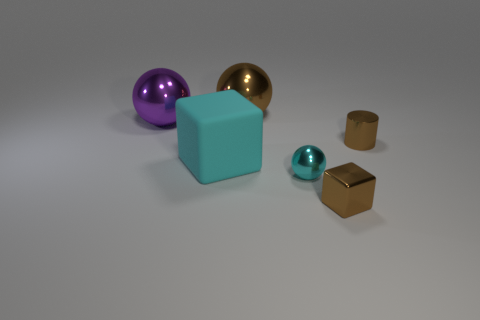Do the purple shiny ball and the brown metallic sphere have the same size?
Provide a short and direct response. Yes. Do the tiny object in front of the small cyan shiny thing and the brown object that is left of the tiny metallic ball have the same material?
Provide a short and direct response. Yes. What is the shape of the brown object in front of the large thing in front of the metal object to the right of the tiny brown metal cube?
Your response must be concise. Cube. Is the number of large brown balls greater than the number of objects?
Make the answer very short. No. Are there any tiny cyan shiny balls?
Your answer should be compact. Yes. How many objects are either big spheres behind the big purple sphere or things that are on the left side of the brown block?
Offer a terse response. 4. Is the color of the large matte thing the same as the cylinder?
Your answer should be very brief. No. Are there fewer big blue cylinders than cyan shiny balls?
Give a very brief answer. Yes. There is a big purple ball; are there any large rubber objects behind it?
Provide a succinct answer. No. Is the material of the cylinder the same as the large brown ball?
Offer a very short reply. Yes. 